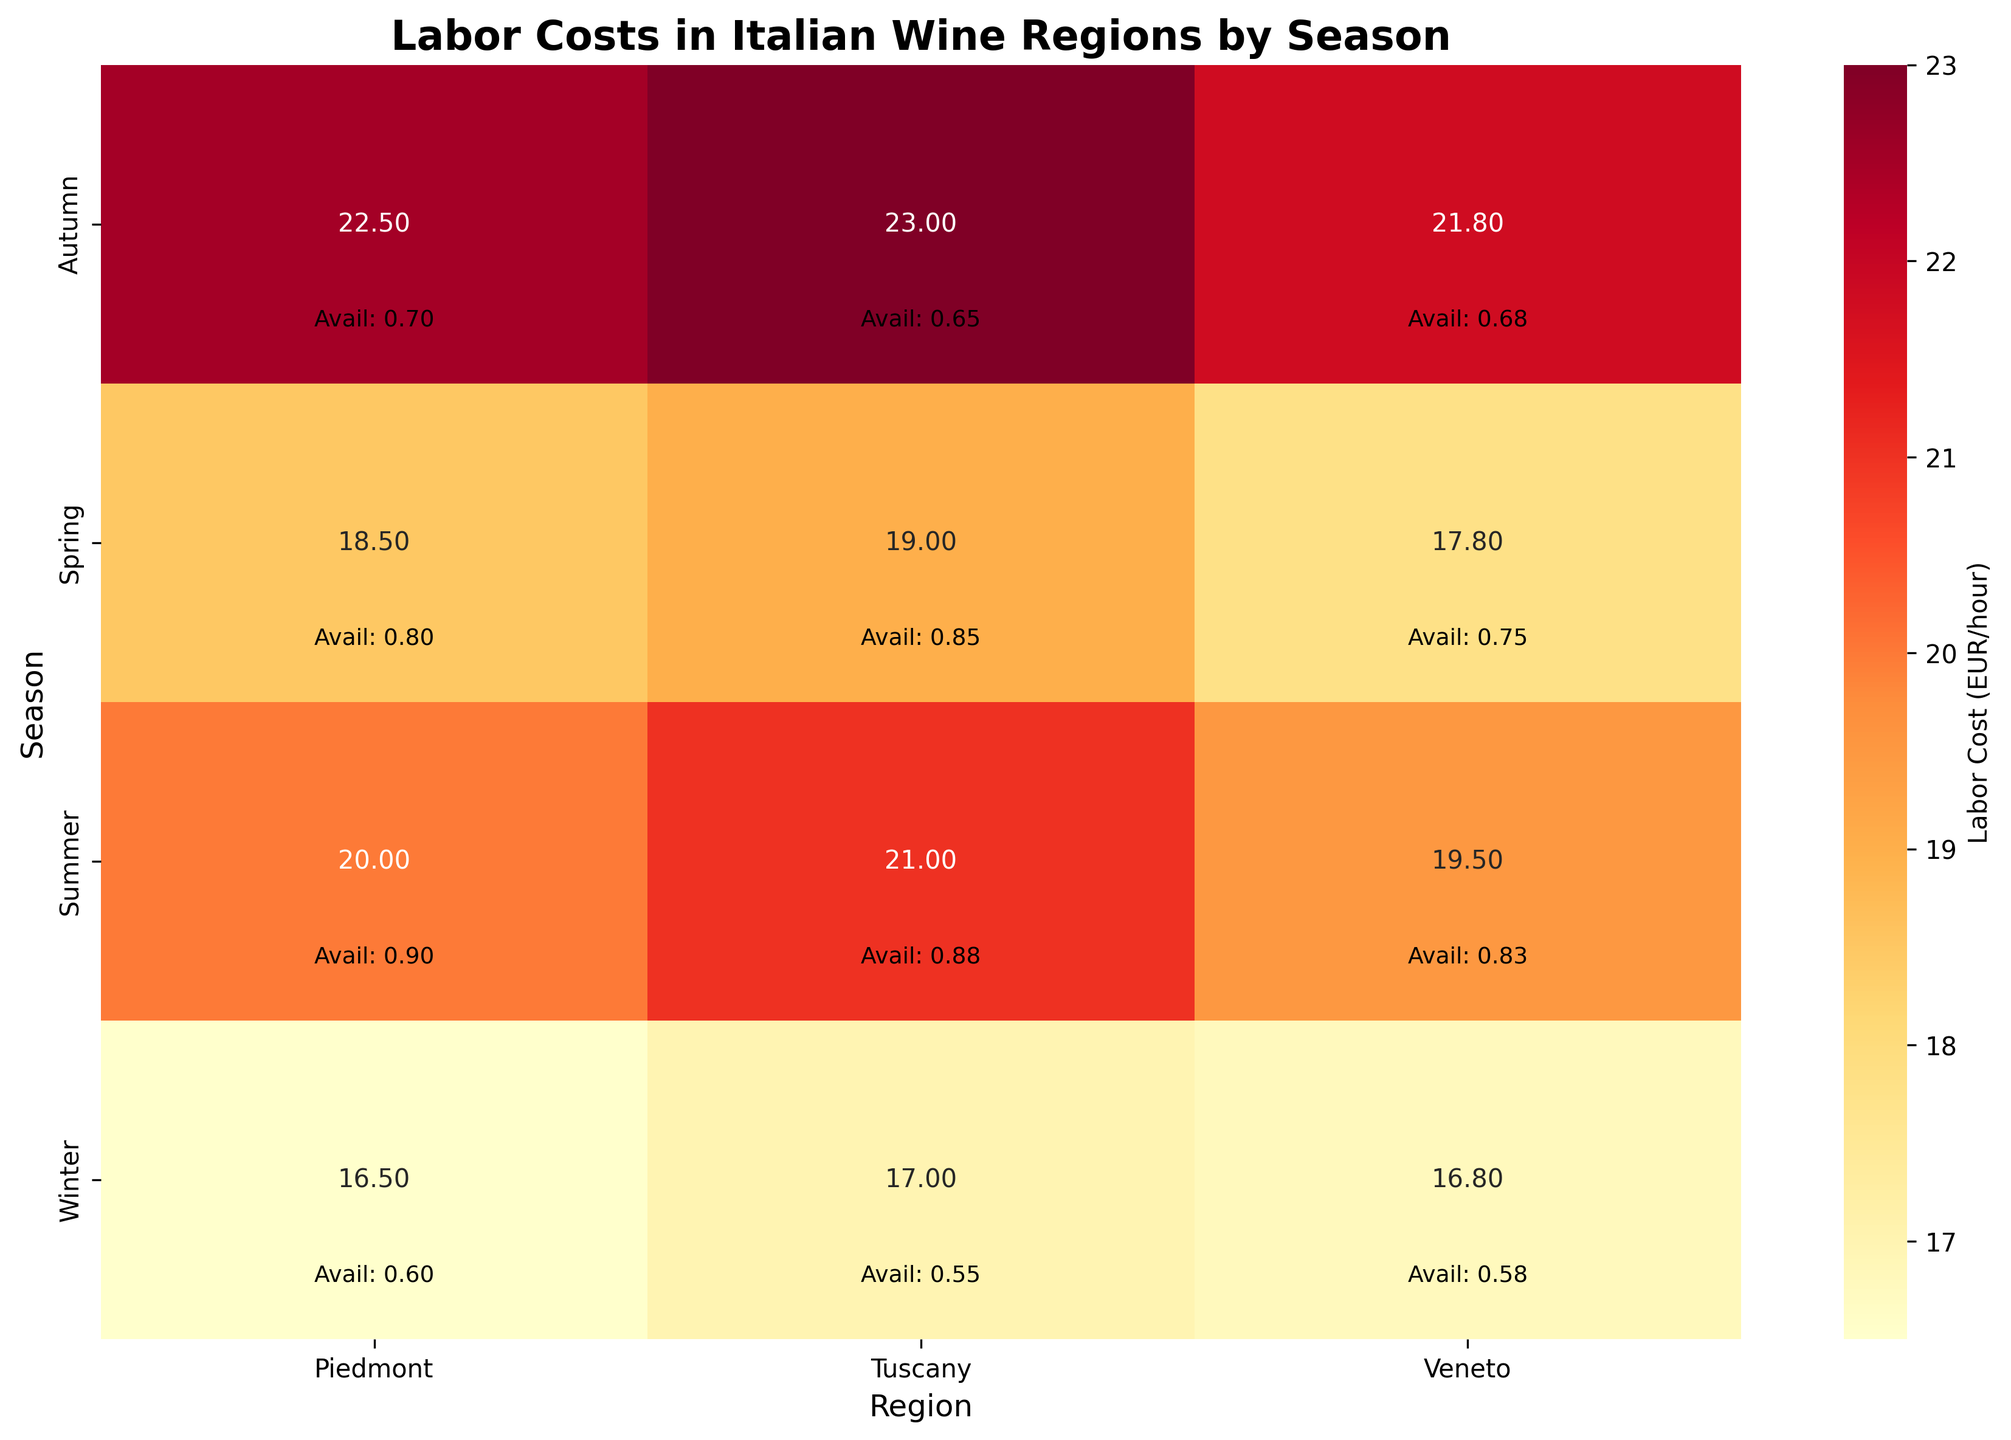what's the title of the figure? The title of any figure is typically displayed at the top in a larger font. Here, it is mentioned as part of the code provided in the title arguments.
Answer: Labor Costs in Italian Wine Regions by Season Which season has the highest labor cost in Veneto? To identify the highest labor cost in Veneto, we look at each season's labor cost for this region. From the data: Spring (17.80), Summer (19.50), Autumn (21.80), Winter (16.80). The highest value is in Autumn.
Answer: Autumn What is the labor cost difference between Summer and Winter in Tuscany? Check Tuscany's labor cost for Summer (21.00) and Winter (17.00). Subtract the Winter value from the Summer value: 21.00 - 17.00.
Answer: 4 EUR/hour Which region has the least labor availability in Autumn? Compare the availability index in Autumn across regions: Piedmont (0.70), Tuscany (0.65), Veneto (0.68). The least availability is in Tuscany.
Answer: Tuscany Between Spring and Summer, which season has higher labor availability in Piedmont? Check Piedmont's availability index for Spring (0.80) and Summer (0.90). Summer has a higher value.
Answer: Summer Which season has the lowest labor cost in Piedmont, and what is it? Look at Piedmont labor costs across the seasons: Spring (18.50), Summer (20.00), Autumn (22.50), Winter (16.50). The lowest value is in Winter.
Answer: Winter, 16.50 What is the average labor cost for Veneto across all seasons? Sum the labor costs for Veneto and divide by the number of seasons: (17.80 + 19.50 + 21.80 + 16.80) / 4. The average is 18.975.
Answer: 18.975 EUR/hour Compare the labor availability index between Spring in Tuscany and Winter in Veneto. Which is higher? Check the availability index for Spring in Tuscany (0.85) and Winter in Veneto (0.58). 0.85 is higher than 0.58.
Answer: Spring in Tuscany How does the labor cost in Summer for Piedmont compare to Tuscany? Look at the labor costs in Summer for Piedmont (20.00) and Tuscany (21.00). Tuscany has a higher labor cost than Piedmont.
Answer: Tuscany has higher labor cost What is the combined labor availability for all seasons in Veneto? Sum the labor availability for Veneto: 0.75 (Spring) + 0.83 (Summer) + 0.68 (Autumn) + 0.58 (Winter). The combined value is 2.84.
Answer: 2.84 